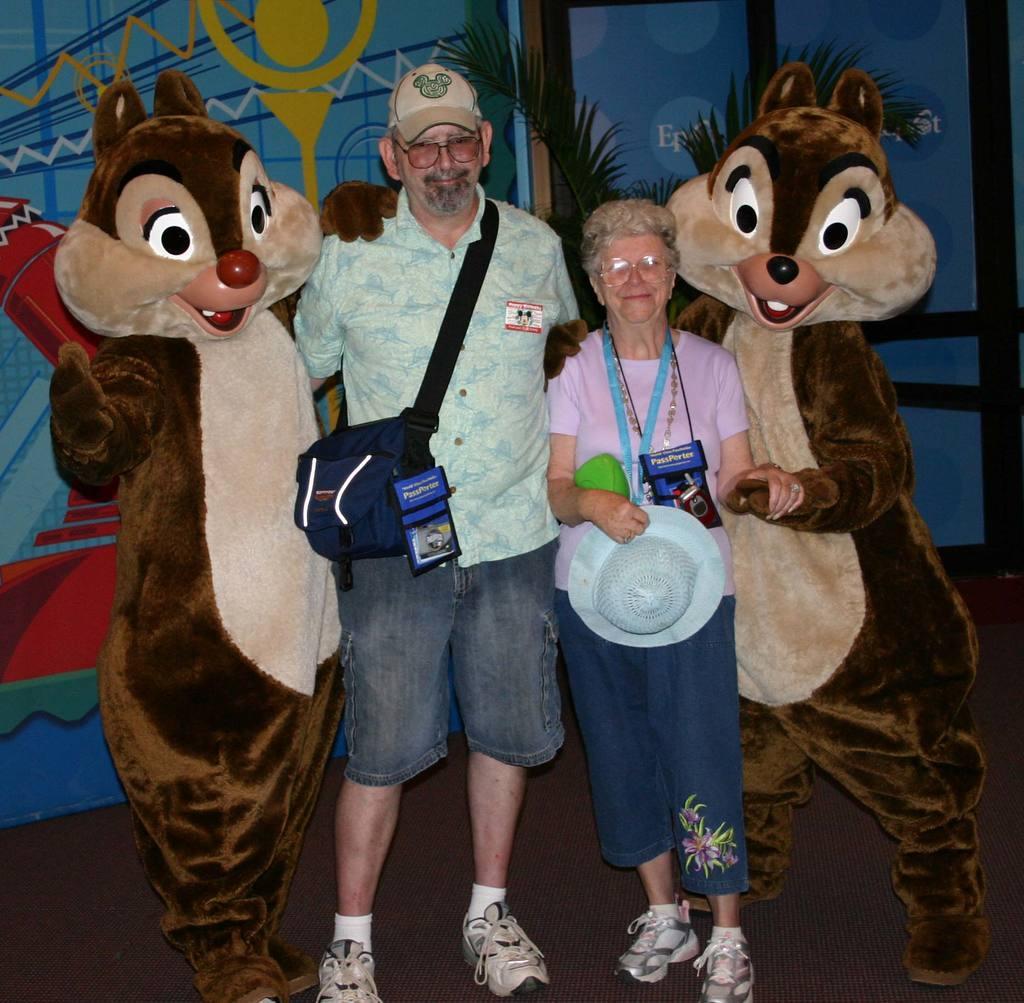Please provide a concise description of this image. In this image we can see a man and a lady standing and smiling. We can see clowns. In the background there is a plant and a wall. We can see a painting on the wall. 